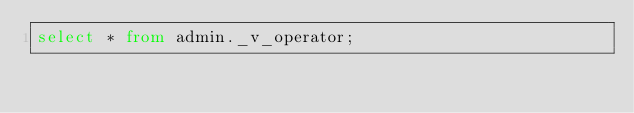Convert code to text. <code><loc_0><loc_0><loc_500><loc_500><_SQL_>select * from admin._v_operator;
</code> 